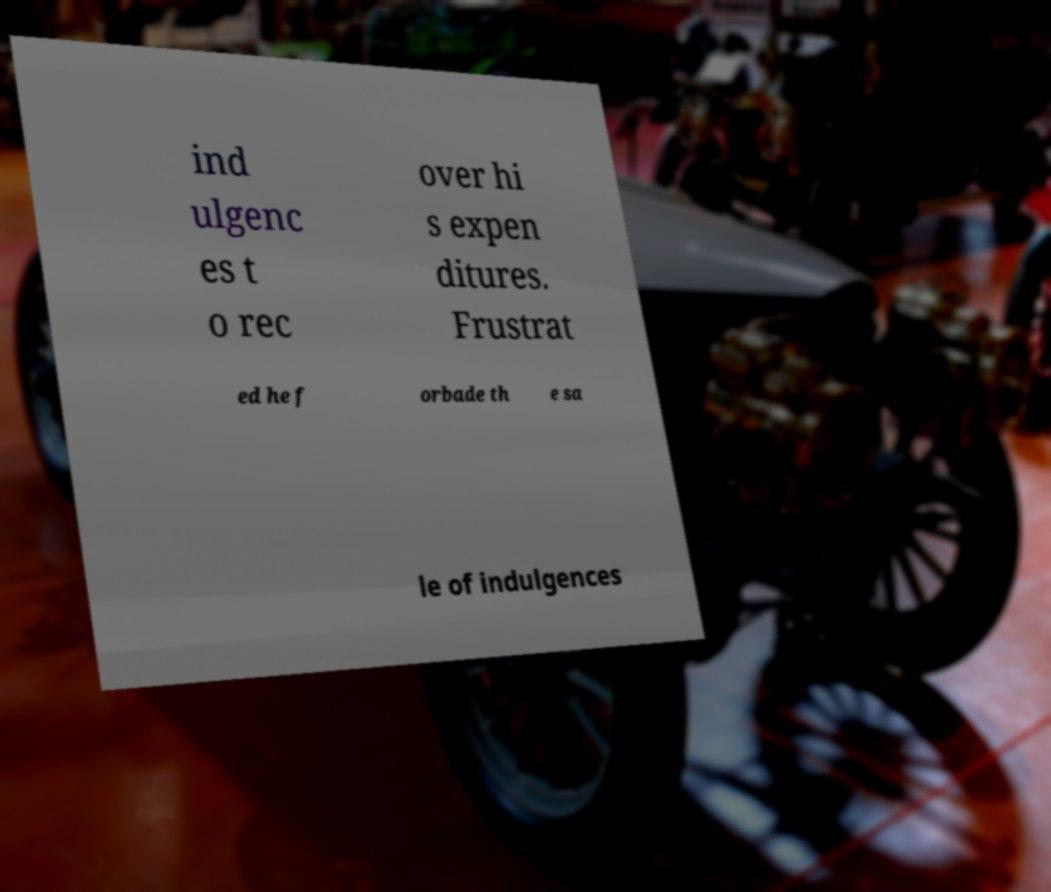There's text embedded in this image that I need extracted. Can you transcribe it verbatim? ind ulgenc es t o rec over hi s expen ditures. Frustrat ed he f orbade th e sa le of indulgences 